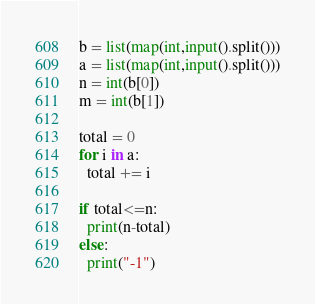<code> <loc_0><loc_0><loc_500><loc_500><_Python_>b = list(map(int,input().split()))
a = list(map(int,input().split()))
n = int(b[0])
m = int(b[1])

total = 0
for i in a:
  total += i
  
if total<=n:
  print(n-total)
else:
  print("-1")</code> 